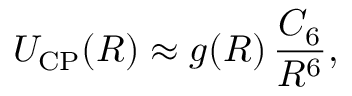Convert formula to latex. <formula><loc_0><loc_0><loc_500><loc_500>U _ { C P } ( R ) \approx g ( R ) \, \frac { C _ { 6 } } { R ^ { 6 } } ,</formula> 